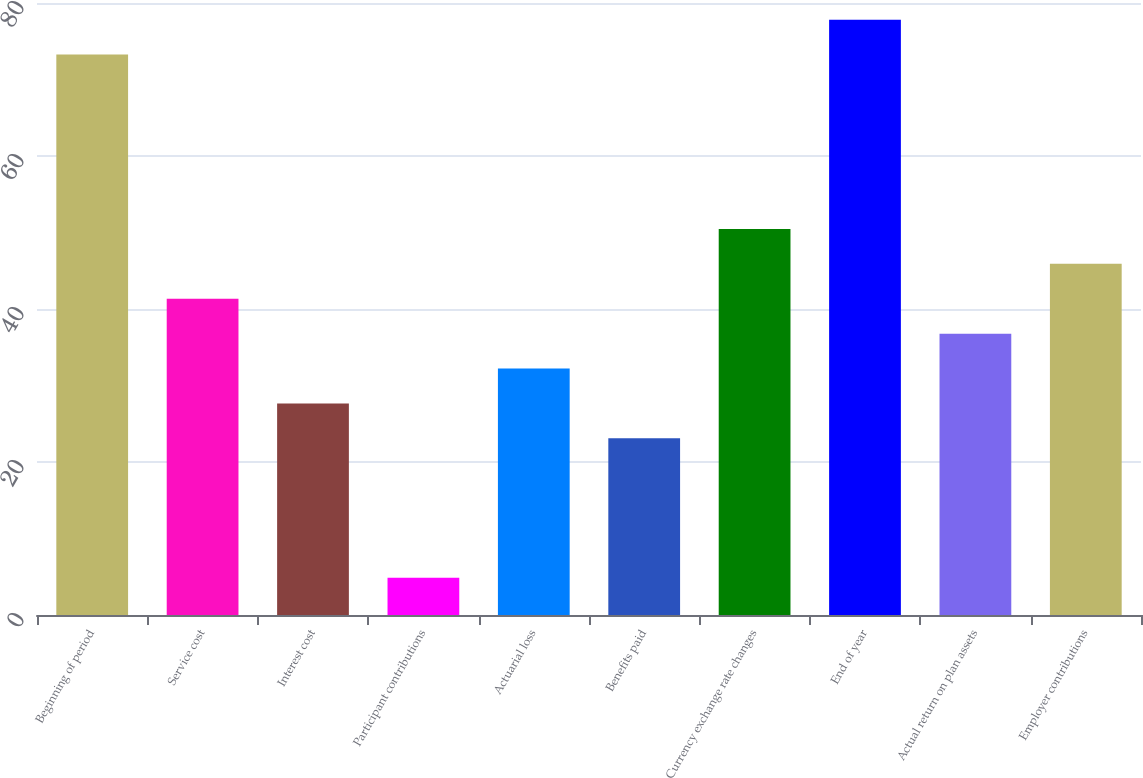Convert chart. <chart><loc_0><loc_0><loc_500><loc_500><bar_chart><fcel>Beginning of period<fcel>Service cost<fcel>Interest cost<fcel>Participant contributions<fcel>Actuarial loss<fcel>Benefits paid<fcel>Currency exchange rate changes<fcel>End of year<fcel>Actual return on plan assets<fcel>Employer contributions<nl><fcel>73.26<fcel>41.34<fcel>27.66<fcel>4.86<fcel>32.22<fcel>23.1<fcel>50.46<fcel>77.82<fcel>36.78<fcel>45.9<nl></chart> 